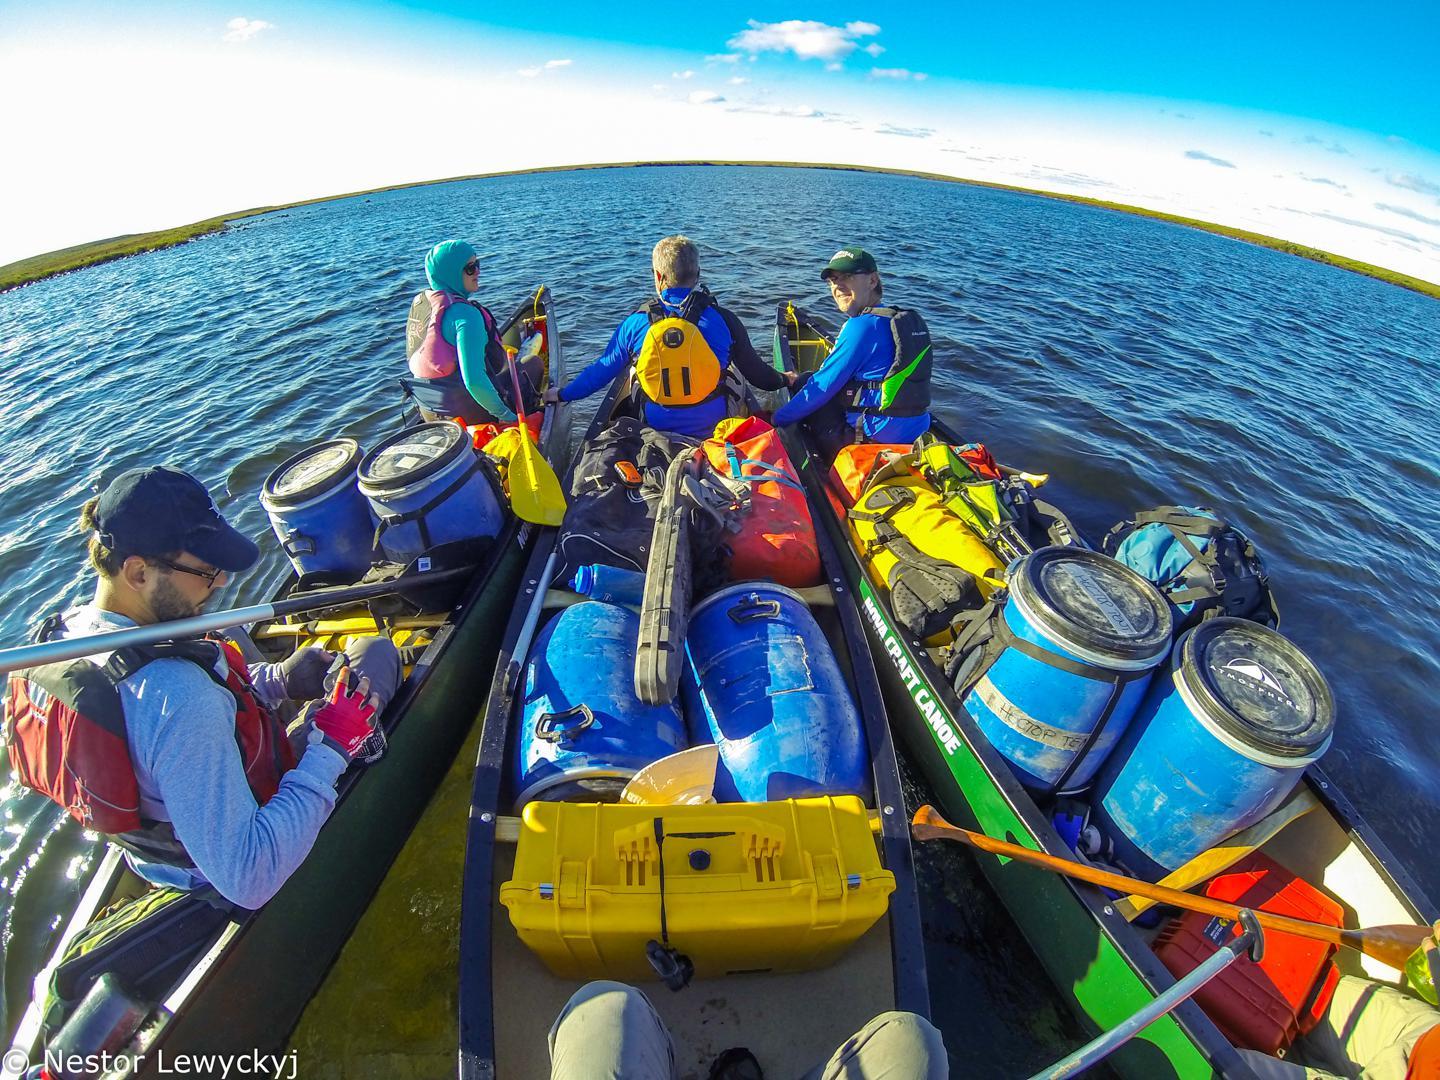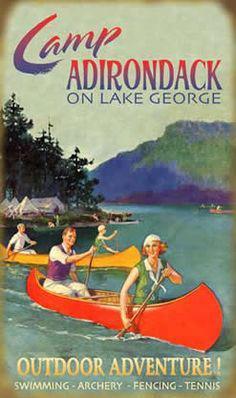The first image is the image on the left, the second image is the image on the right. Evaluate the accuracy of this statement regarding the images: "There are at least six boats in the image on the right.". Is it true? Answer yes or no. No. 